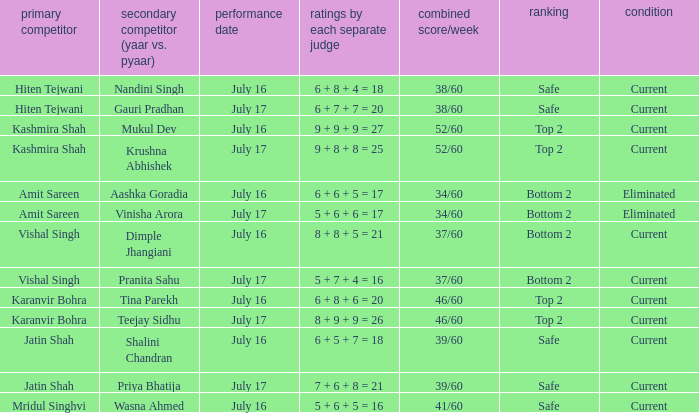What position did the team with the total score of 41/60 get? Safe. 